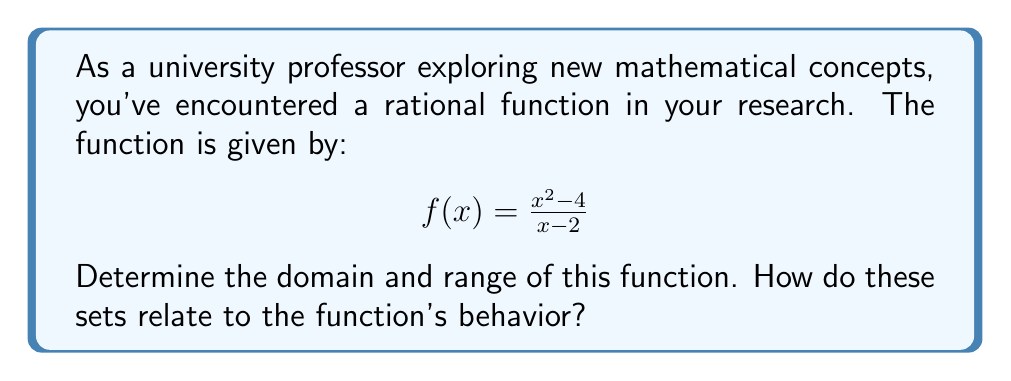What is the answer to this math problem? Let's approach this step-by-step:

1) Domain:
   The domain of a rational function includes all real numbers except those that make the denominator zero. 
   
   Set the denominator to zero and solve:
   $x - 2 = 0$
   $x = 2$
   
   Therefore, 2 is excluded from the domain.

2) Simplification:
   We can simplify the function by factoring the numerator:
   $$f(x) = \frac{(x+2)(x-2)}{x-2}$$
   
   The $(x-2)$ term cancels out, giving us:
   $$f(x) = x + 2, \text{ where } x \neq 2$$

3) Behavior at x = 2:
   As $x$ approaches 2 from either side, $f(x)$ approaches 4.
   However, $f(2)$ is undefined due to division by zero in the original form.

4) Range:
   Since the simplified function is linear (except at x = 2), it can take on any real value except 4.
   
   To verify this, we can solve:
   $y = x + 2$
   $x = y - 2$
   
   This is defined for all real y except 4, because when y = 4, x would equal 2, which is not in the domain.

Therefore, the range is all real numbers except 4, which we can write as $\mathbb{R} \setminus \{4\}$.

This analysis shows how the domain restriction at x = 2 creates a corresponding "hole" in the range at y = 4, demonstrating the intimate connection between a function's domain and range.
Answer: Domain: $\mathbb{R} \setminus \{2\}$
Range: $\mathbb{R} \setminus \{4\}$ 